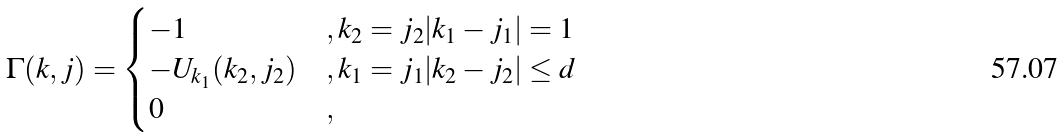Convert formula to latex. <formula><loc_0><loc_0><loc_500><loc_500>\Gamma ( k , j ) = \begin{cases} - 1 & , k _ { 2 } = j _ { 2 } | k _ { 1 } - j _ { 1 } | = 1 \\ - U _ { k _ { 1 } } ( k _ { 2 } , j _ { 2 } ) & , k _ { 1 } = j _ { 1 } | k _ { 2 } - j _ { 2 } | \leq d \\ 0 & , \end{cases}</formula> 